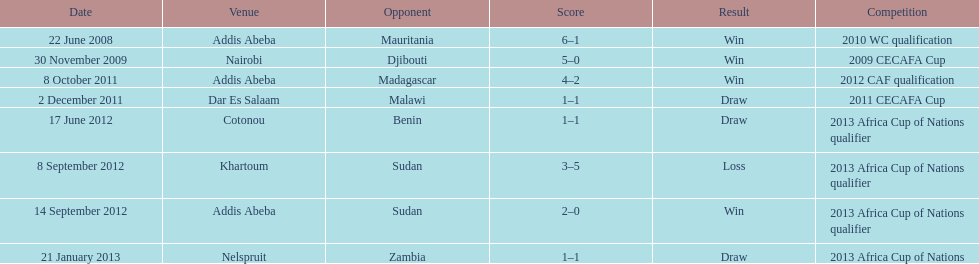Parse the table in full. {'header': ['Date', 'Venue', 'Opponent', 'Score', 'Result', 'Competition'], 'rows': [['22 June 2008', 'Addis Abeba', 'Mauritania', '6–1', 'Win', '2010 WC qualification'], ['30 November 2009', 'Nairobi', 'Djibouti', '5–0', 'Win', '2009 CECAFA Cup'], ['8 October 2011', 'Addis Abeba', 'Madagascar', '4–2', 'Win', '2012 CAF qualification'], ['2 December 2011', 'Dar Es Salaam', 'Malawi', '1–1', 'Draw', '2011 CECAFA Cup'], ['17 June 2012', 'Cotonou', 'Benin', '1–1', 'Draw', '2013 Africa Cup of Nations qualifier'], ['8 September 2012', 'Khartoum', 'Sudan', '3–5', 'Loss', '2013 Africa Cup of Nations qualifier'], ['14 September 2012', 'Addis Abeba', 'Sudan', '2–0', 'Win', '2013 Africa Cup of Nations qualifier'], ['21 January 2013', 'Nelspruit', 'Zambia', '1–1', 'Draw', '2013 Africa Cup of Nations']]} Number of different teams listed on the chart 7. 